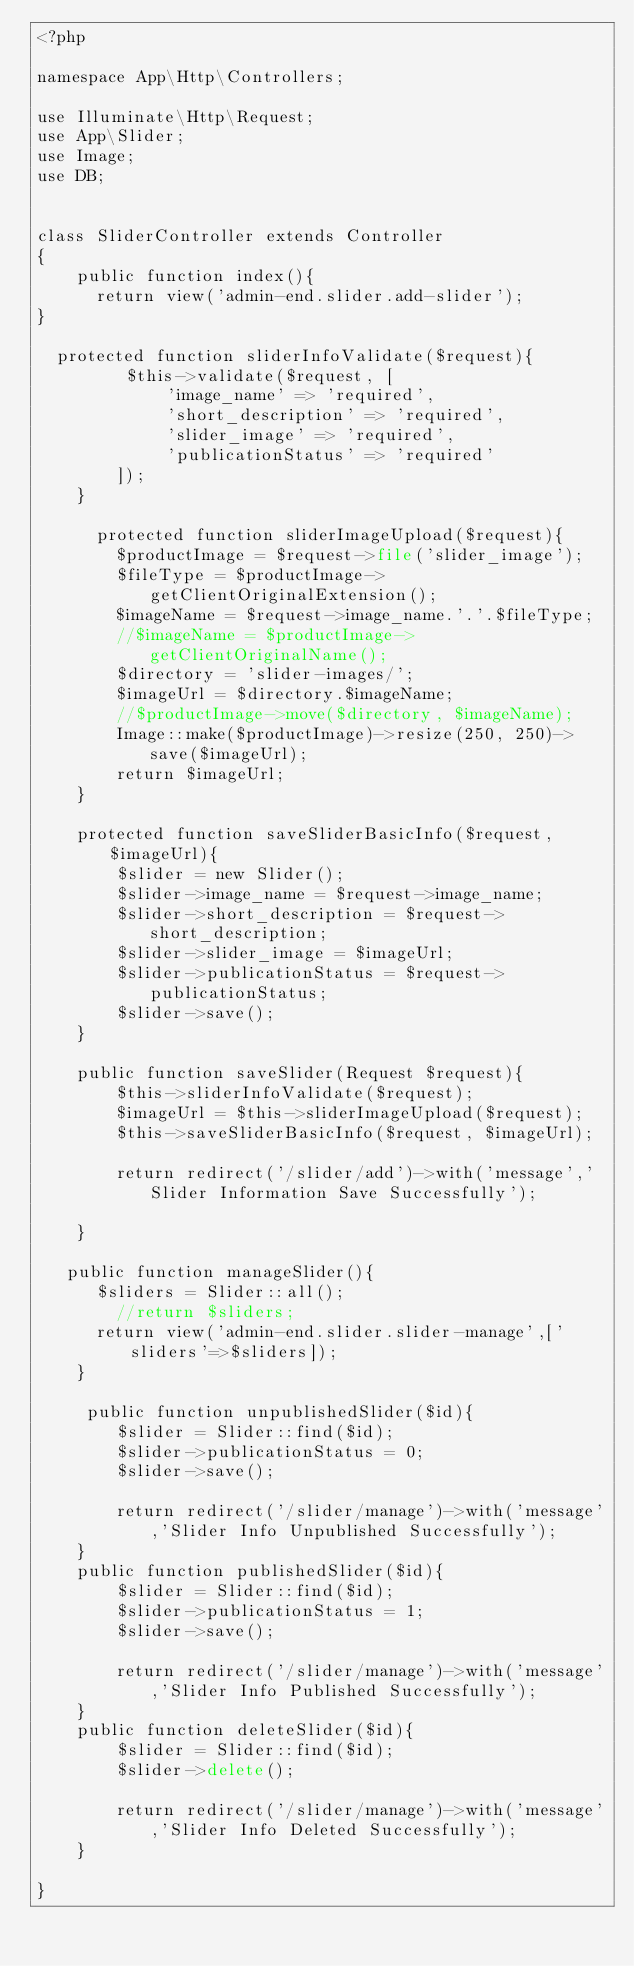<code> <loc_0><loc_0><loc_500><loc_500><_PHP_><?php

namespace App\Http\Controllers;

use Illuminate\Http\Request;
use App\Slider;
use Image;
use DB;


class SliderController extends Controller
{
    public function index(){
      return view('admin-end.slider.add-slider');
}

	protected function sliderInfoValidate($request){
         $this->validate($request, [
             'image_name' => 'required',
             'short_description' => 'required',
             'slider_image' => 'required',
             'publicationStatus' => 'required'
        ]);
    }

      protected function sliderImageUpload($request){
        $productImage = $request->file('slider_image');
        $fileType = $productImage->getClientOriginalExtension();
        $imageName = $request->image_name.'.'.$fileType;
        //$imageName = $productImage->getClientOriginalName();
        $directory = 'slider-images/';
        $imageUrl = $directory.$imageName;
        //$productImage->move($directory, $imageName);
        Image::make($productImage)->resize(250, 250)->save($imageUrl);
        return $imageUrl;
    }

    protected function saveSliderBasicInfo($request, $imageUrl){
        $slider = new Slider();
        $slider->image_name = $request->image_name;
        $slider->short_description = $request->short_description;
        $slider->slider_image = $imageUrl;
        $slider->publicationStatus = $request->publicationStatus;
        $slider->save();
    }

    public function saveSlider(Request $request){
        $this->sliderInfoValidate($request);
        $imageUrl = $this->sliderImageUpload($request);
        $this->saveSliderBasicInfo($request, $imageUrl);
       
        return redirect('/slider/add')->with('message','Slider Information Save Successfully');

    }

   public function manageSlider(){
    	$sliders = Slider::all();
        //return $sliders;
    	return view('admin-end.slider.slider-manage',['sliders'=>$sliders]);
    }

     public function unpublishedSlider($id){
        $slider = Slider::find($id);
        $slider->publicationStatus = 0;
        $slider->save();
        
        return redirect('/slider/manage')->with('message','Slider Info Unpublished Successfully');
    }
    public function publishedSlider($id){
        $slider = Slider::find($id);
        $slider->publicationStatus = 1;
        $slider->save();
        
        return redirect('/slider/manage')->with('message','Slider Info Published Successfully');
    }
    public function deleteSlider($id){
        $slider = Slider::find($id);
        $slider->delete();
        
        return redirect('/slider/manage')->with('message','Slider Info Deleted Successfully');
    }

}</code> 